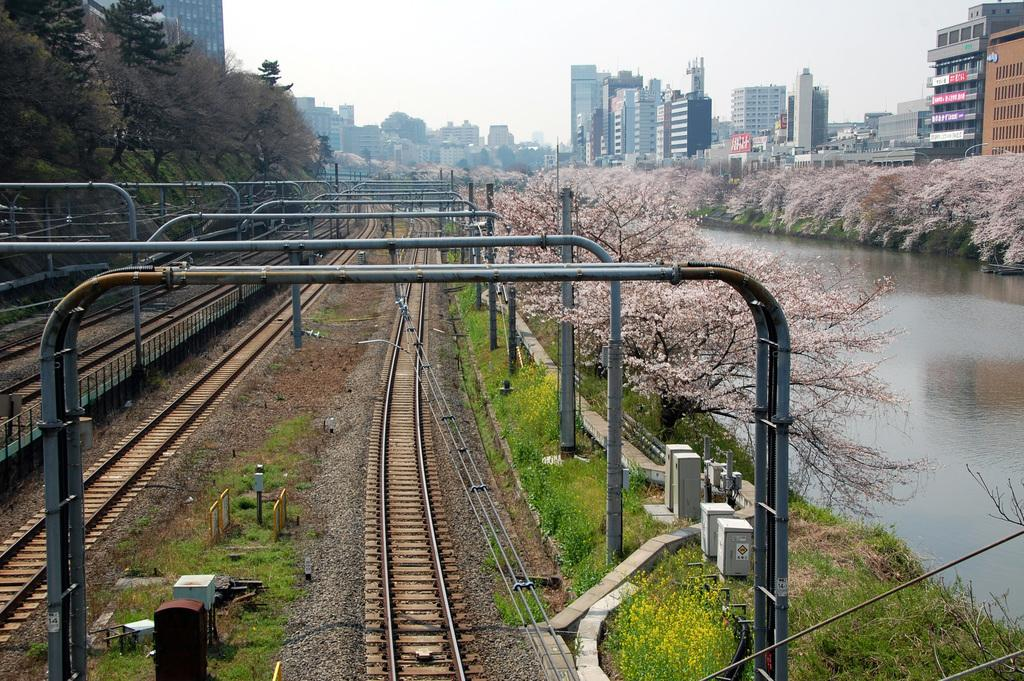What can be seen on the ground in the image? There are railway tracks on the ground in the image. What is present alongside the railway tracks? There are trees on both sides of the railway tracks. What natural element is visible in the image? Water is visible in the image. What type of structures can be seen in the background? There are buildings visible in the background of the image. What type of brass instrument is being played by the fireman in the image? There is no brass instrument or fireman present in the image. 